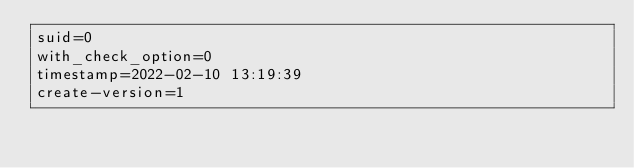Convert code to text. <code><loc_0><loc_0><loc_500><loc_500><_VisualBasic_>suid=0
with_check_option=0
timestamp=2022-02-10 13:19:39
create-version=1</code> 